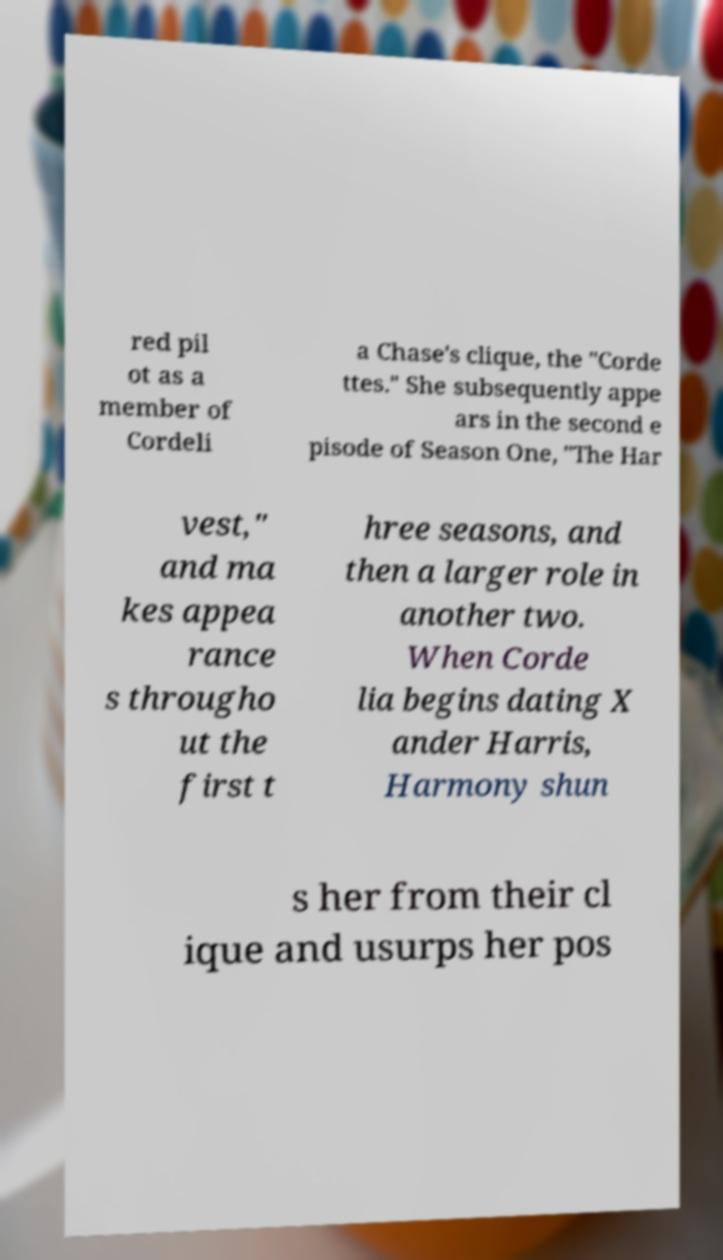Please read and relay the text visible in this image. What does it say? red pil ot as a member of Cordeli a Chase's clique, the "Corde ttes." She subsequently appe ars in the second e pisode of Season One, "The Har vest," and ma kes appea rance s througho ut the first t hree seasons, and then a larger role in another two. When Corde lia begins dating X ander Harris, Harmony shun s her from their cl ique and usurps her pos 